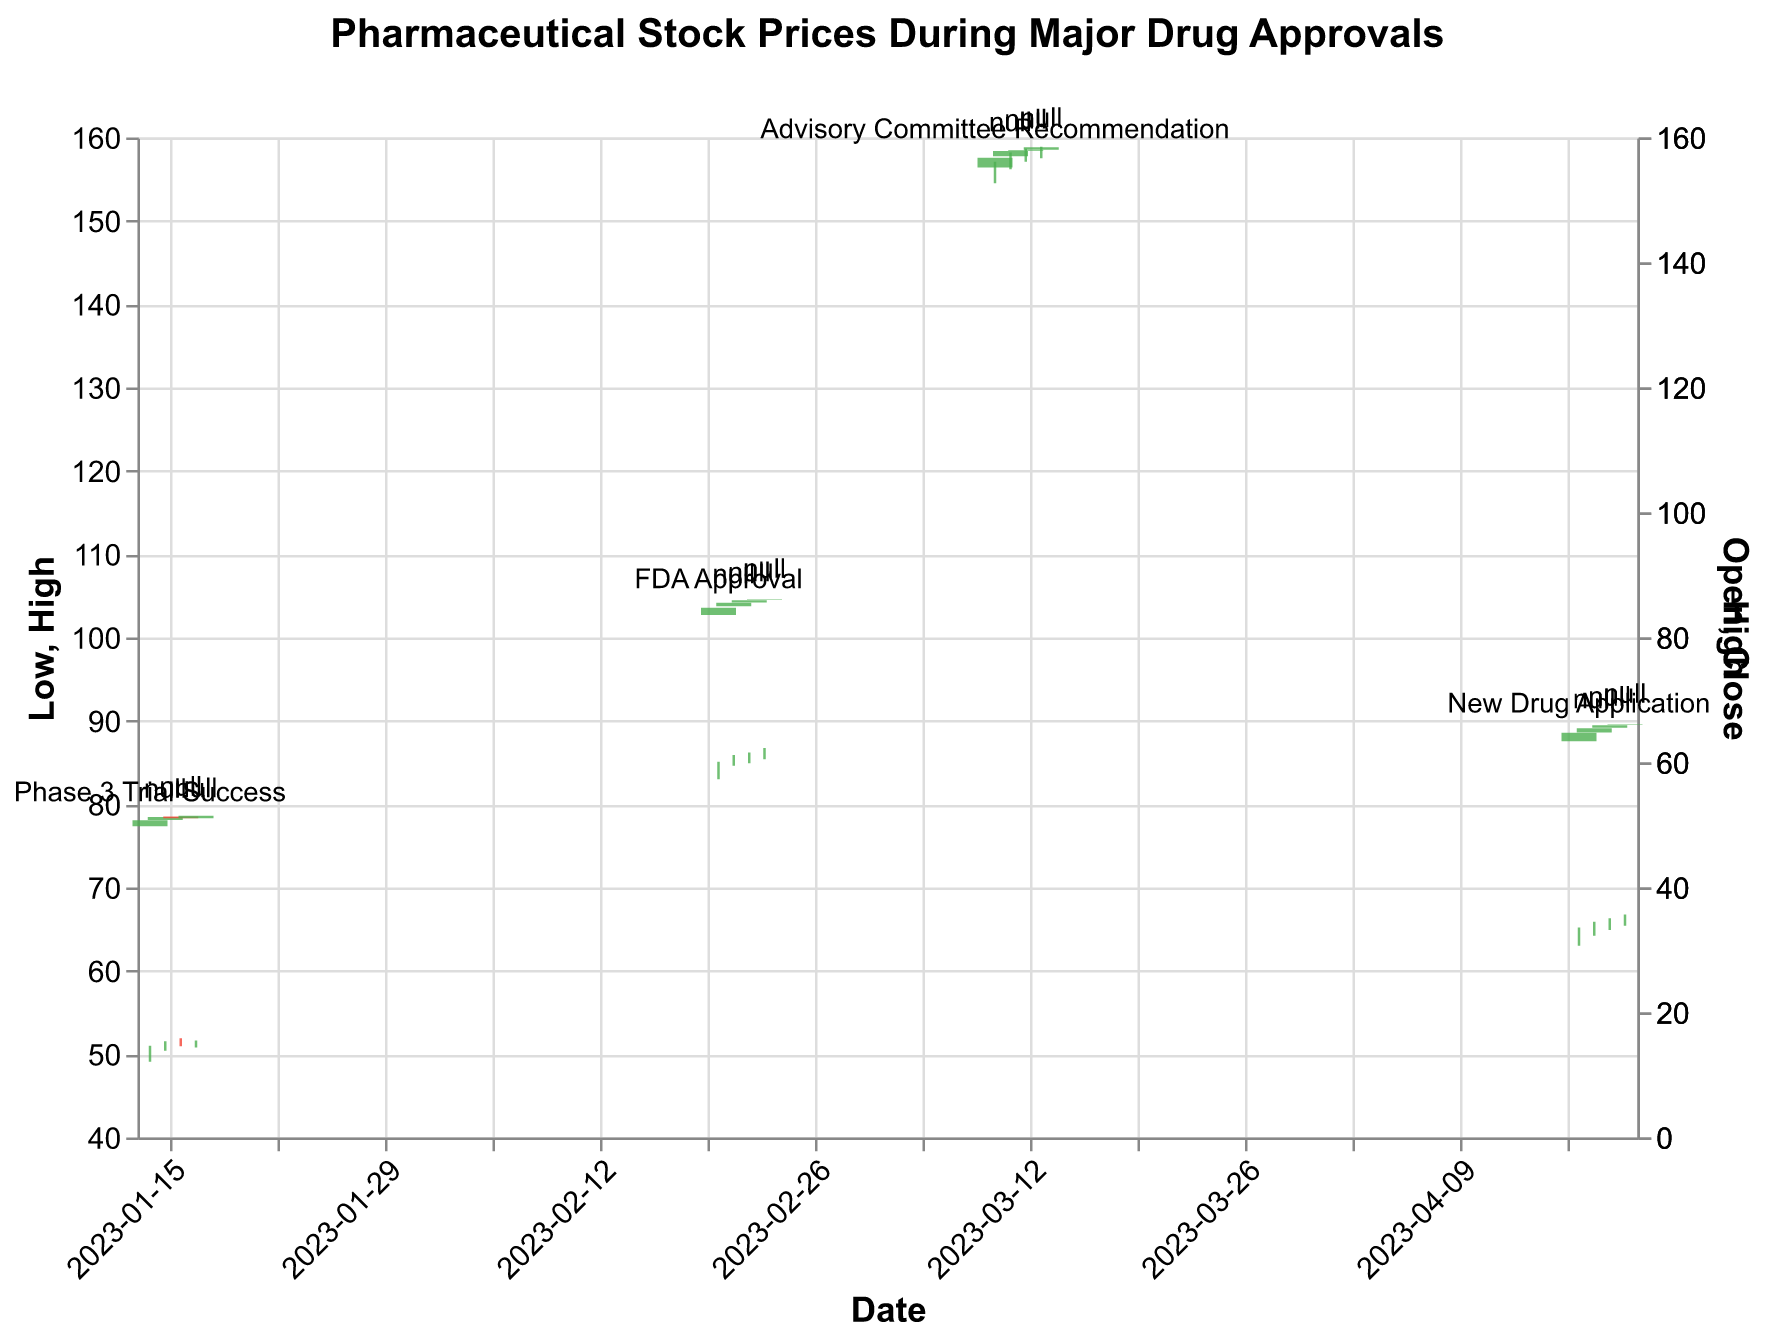What is the title of the figure? The title is displayed at the top of the figure and provides context for the data being shown. Here, it reads "Pharmaceutical Stock Prices During Major Drug Approvals," indicating that the figure shows stock prices of pharmaceutical companies during key drug approval events.
Answer: Pharmaceutical Stock Prices During Major Drug Approvals What events are annotated in the figure? By looking at the text annotations above certain candlesticks, we can identify the events related to the stock prices. The events listed are "Phase 3 Trial Success," "FDA Approval," "Advisory Committee Recommendation," and "New Drug Application."
Answer: Phase 3 Trial Success, FDA Approval, Advisory Committee Recommendation, New Drug Application Which company's stock price had the highest closing value during an event, and what was this value? To determine this, observe the closing prices at the top of the candlesticks where events are annotated. JNJ had the highest closing value with a price of $156.75 during the "Advisory Committee Recommendation" event.
Answer: JNJ, $156.75 Compare the stock price movement of MRK and PFE following their respective events. Which one showed a more significant increase in closing price? For MRK, compare the closing prices from February 20 ($84.75) to February 23 ($86.10). For PFE, compare January 14 ($50.75) to January 17 ($51.50). MRK increased by $1.35, while PFE increased by $0.75. Thus, MRK had a more significant increase.
Answer: MRK What was the stock price change for AZN before and after the "New Drug Application" event? Examine the closing prices on April 17, which is the event date ($64.75), and April 20 ($66.10). Subtract the closing price on April 17 from April 20 to get the change: $66.10 - $64.75 = $1.35.
Answer: $1.35 How many days did it take for JNJ's stock to close higher than the opening price after the "Advisory Committee Recommendation"? Observe the candlestick shapes and colors for JNJ from March 10 to March 13. The closing prices are greater than the opening prices for all four days, meaning it closed higher every day during this period.
Answer: 4 days During which event did the stock of JNJ rise the most in a single day, and by how much did it rise? Look for the daily difference between the opening and closing prices for JNJ around the event annotations. The largest increase was from March 10 to March 11 (opening at $155.20 and closing at $157.85), resulting in an increase of $2.65.
Answer: Advisory Committee Recommendation, $2.65 Which company's stock experienced the highest trading volume during an event, and what was the volume? Review the text labels for trading volumes next to each event. PFE had the highest trading volume of 12,032,000 shares during the "Phase 3 Trial Success" event.
Answer: PFE, 12,032,000 Compare the stock close price of AZN on April 17 with the close price of MRK on February 20. Which one was higher? Look at the close prices of AZN on April 17 ($64.75) and MRK on February 20 ($84.75). The close price of MRK was higher compared to AZN.
Answer: MRK Which event resulted in the largest increase in the stock’s high price on the day it was announced compared to the previous day for any company? Check daily high prices before and after each event. The largest increase can be found for MRK, which increased from $83.60 on February 20 to $85.90 on February 21. The increase was $2.30.
Answer: FDA Approval for MRK, $2.30 